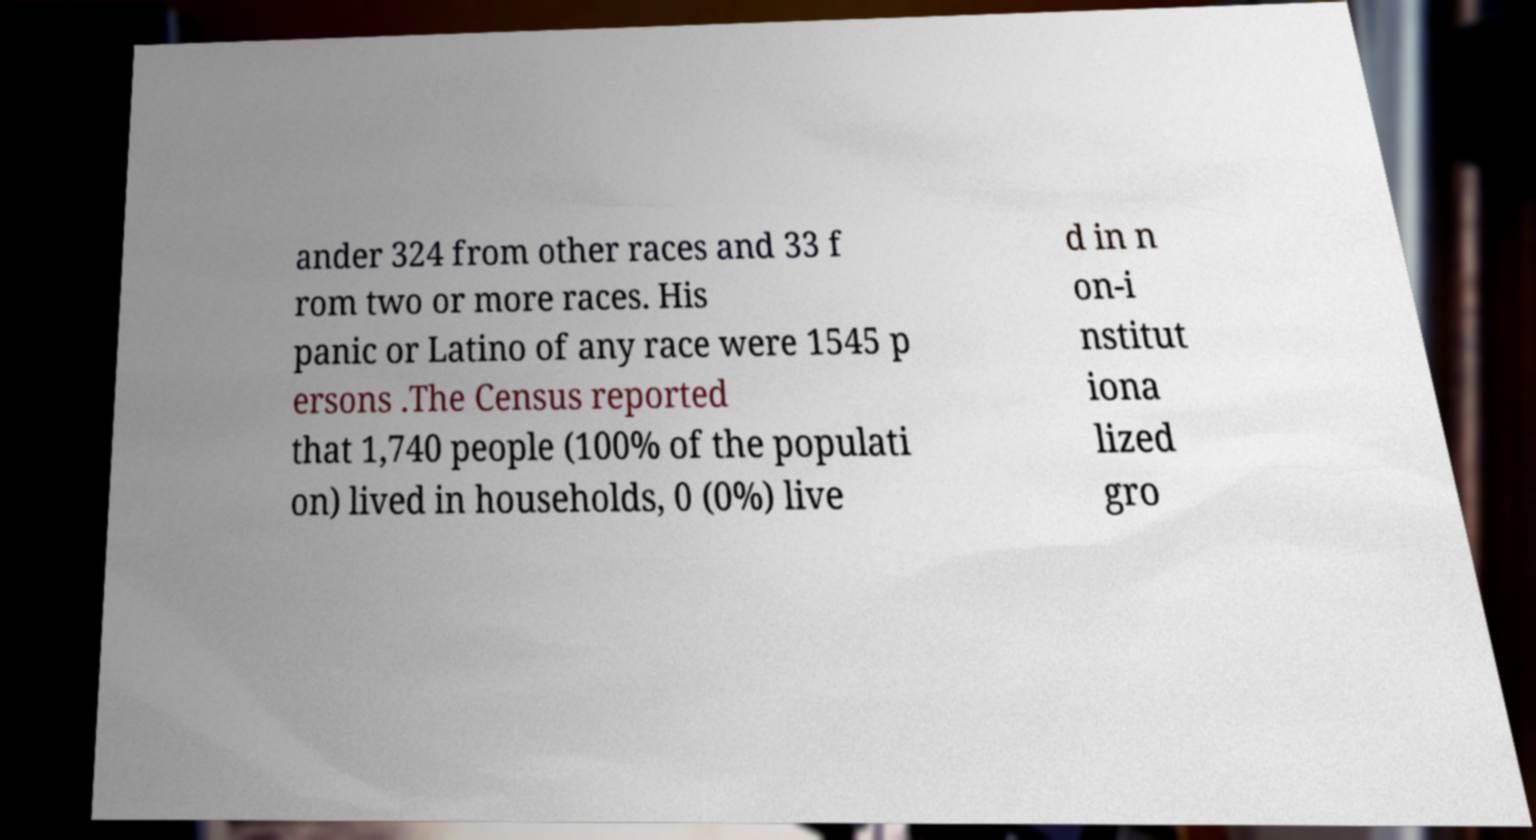I need the written content from this picture converted into text. Can you do that? ander 324 from other races and 33 f rom two or more races. His panic or Latino of any race were 1545 p ersons .The Census reported that 1,740 people (100% of the populati on) lived in households, 0 (0%) live d in n on-i nstitut iona lized gro 